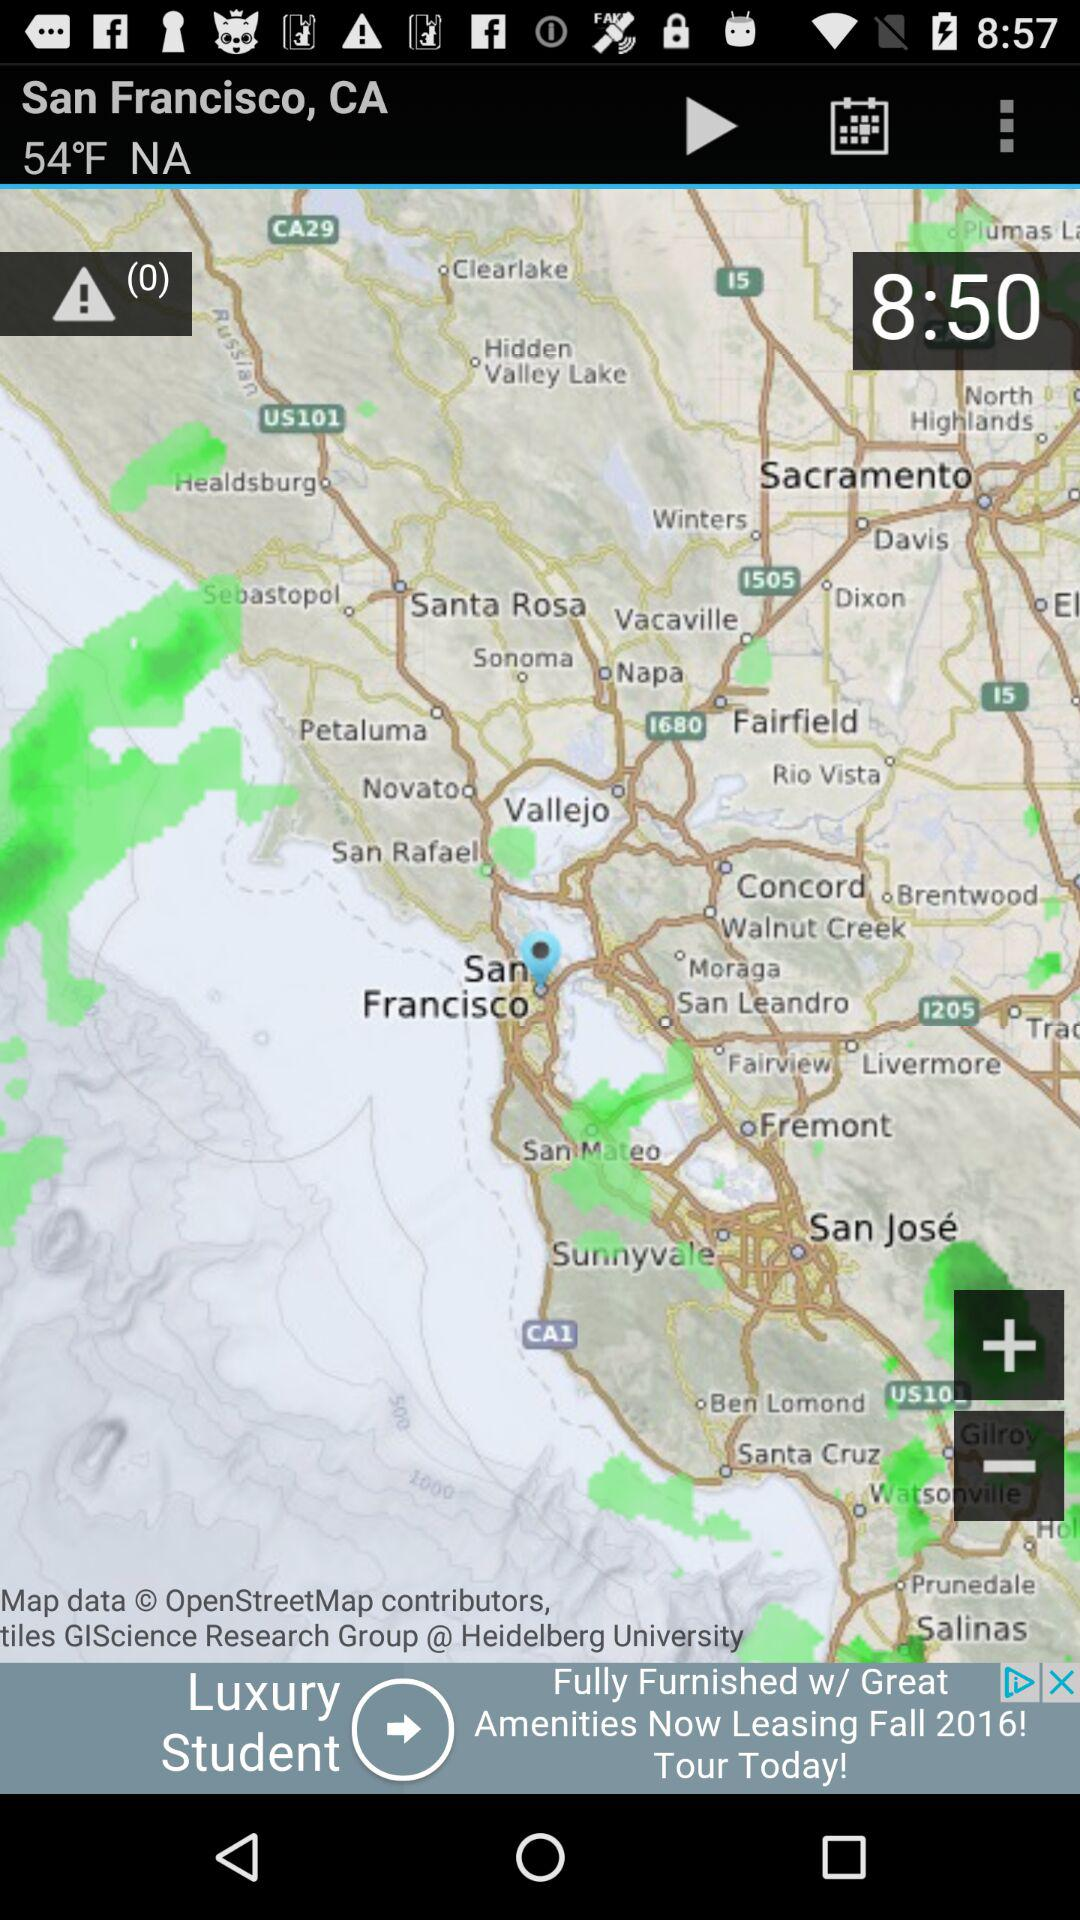In San Francisco, how is the weather?
When the provided information is insufficient, respond with <no answer>. <no answer> 